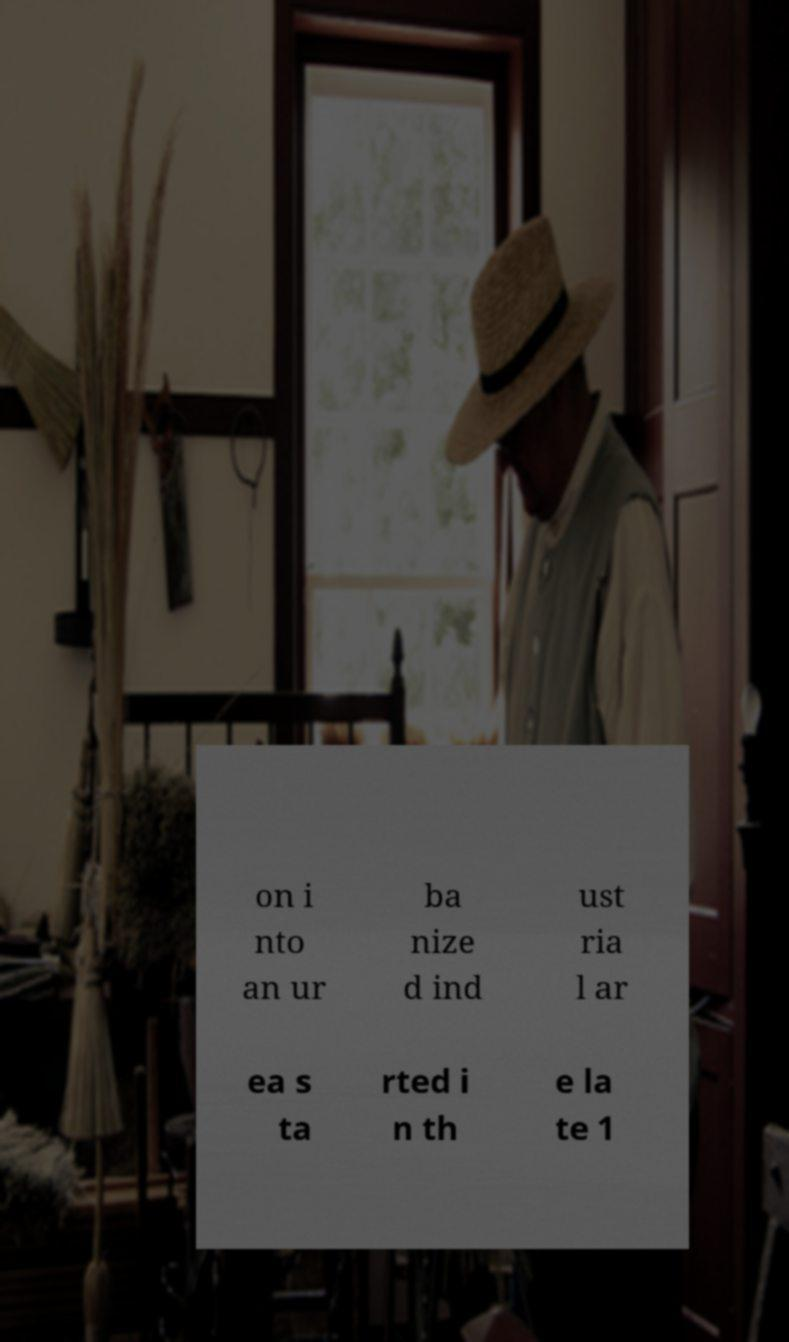Can you read and provide the text displayed in the image?This photo seems to have some interesting text. Can you extract and type it out for me? on i nto an ur ba nize d ind ust ria l ar ea s ta rted i n th e la te 1 